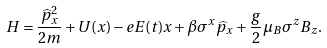<formula> <loc_0><loc_0><loc_500><loc_500>H = \frac { \widehat { p } _ { x } ^ { 2 } } { 2 m } + U ( x ) - e E ( t ) x + \beta \sigma ^ { x } \widehat { p } _ { x } + \frac { g } { 2 } \mu _ { B } \sigma ^ { z } B _ { z } .</formula> 